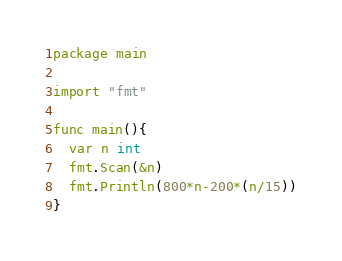Convert code to text. <code><loc_0><loc_0><loc_500><loc_500><_Go_>package main

import "fmt"

func main(){
  var n int
  fmt.Scan(&n)
  fmt.Println(800*n-200*(n/15))
}
</code> 